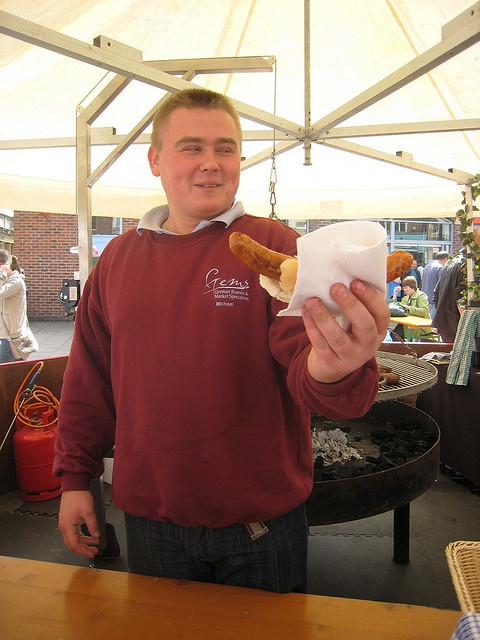Describe the objects in this image and their specific colors. I can see people in tan, maroon, black, and brown tones, dining table in tan, brown, and maroon tones, sandwich in tan, brown, red, and maroon tones, people in tan, white, and gray tones, and people in tan, black, and gray tones in this image. 